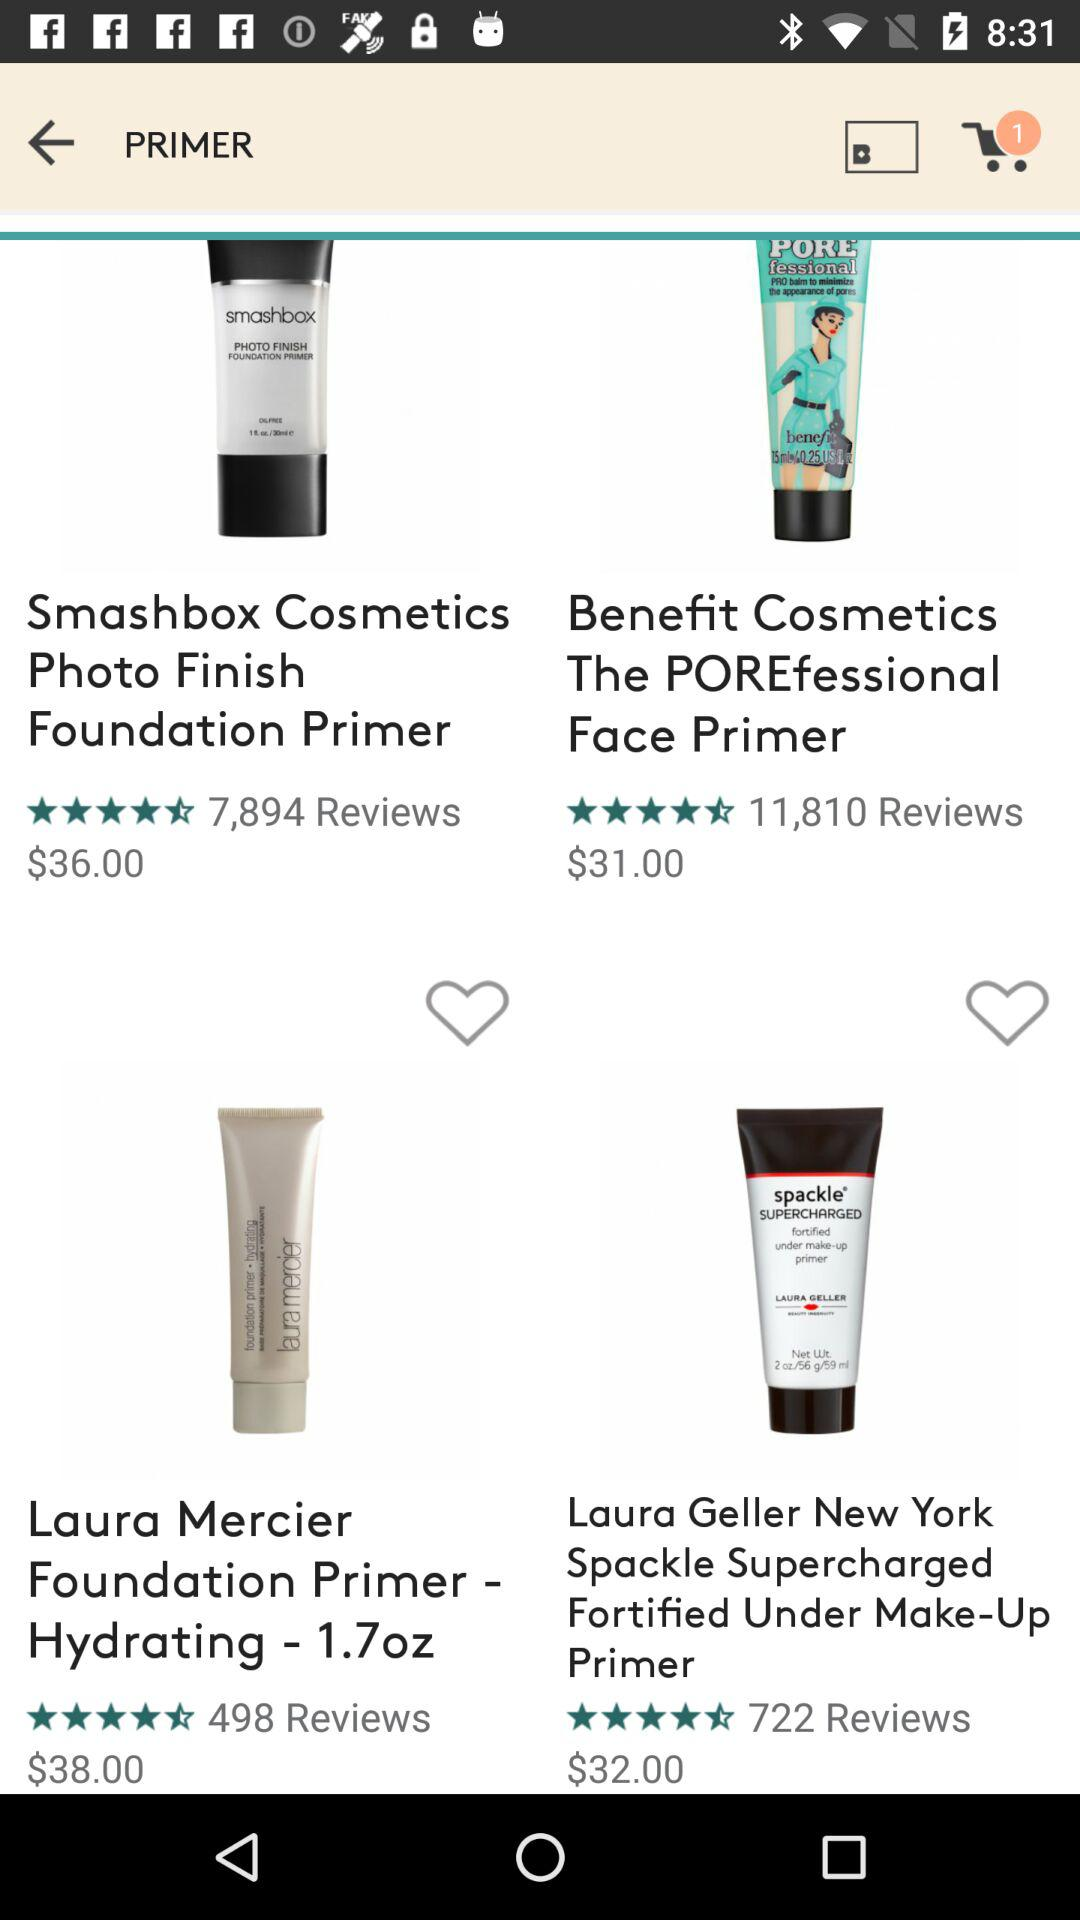What's the price of Smashbox primer? The price is $36.00. 